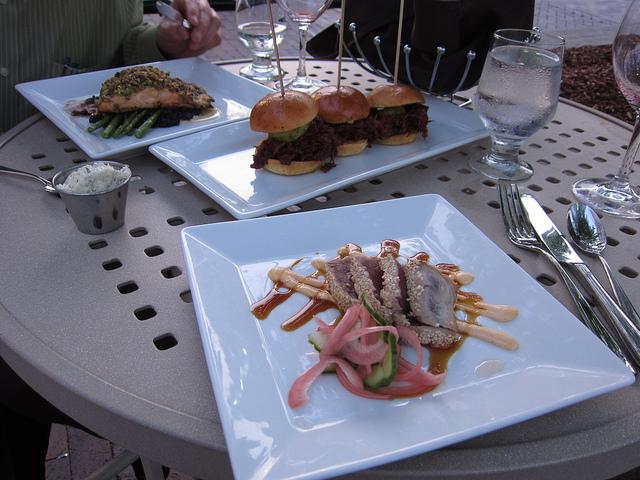Does the table have holes?
Answer briefly. Yes. Is there meat on the table?
Give a very brief answer. Yes. Is this an Oriental meal?
Be succinct. No. 